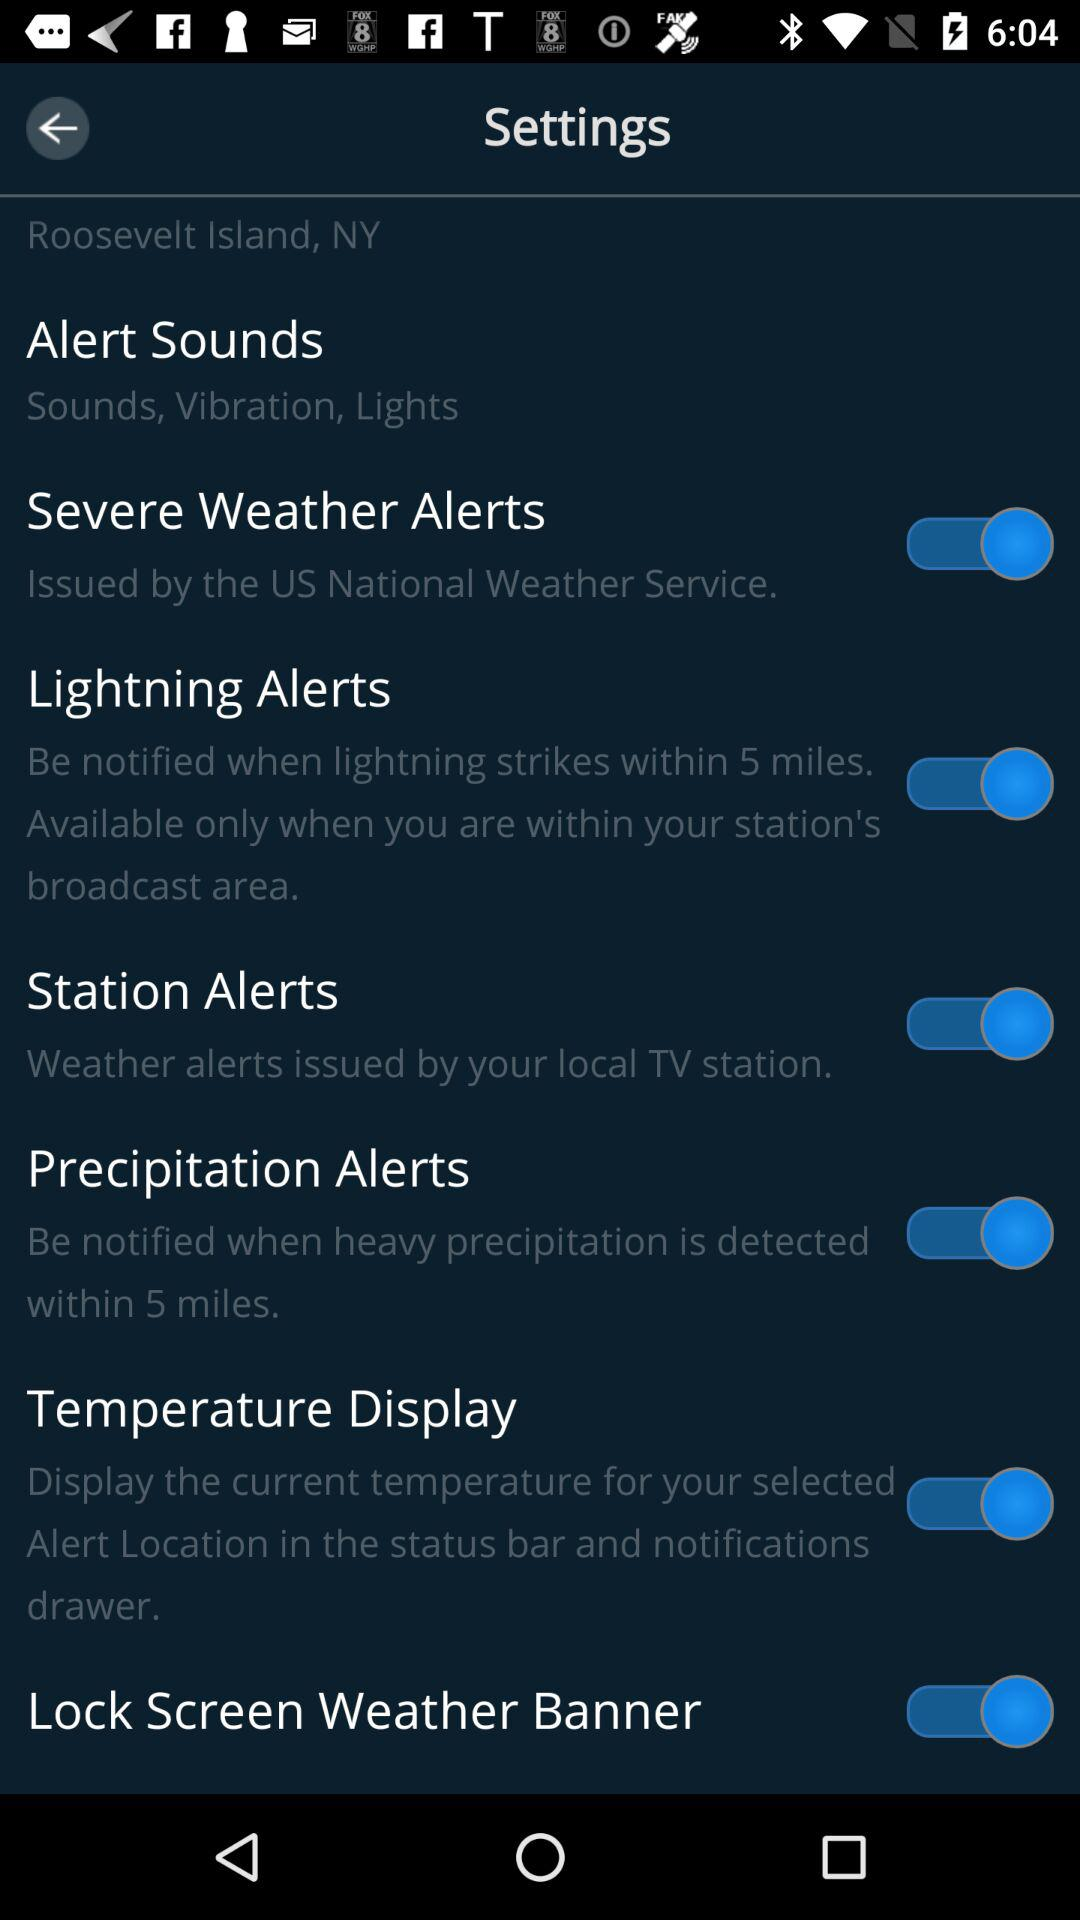How many alerts are available for the user to select?
Answer the question using a single word or phrase. 4 